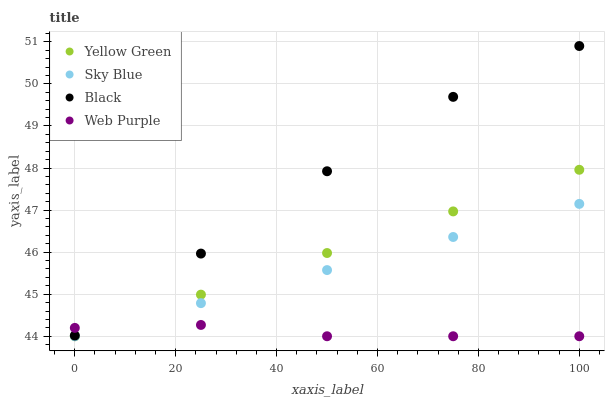Does Web Purple have the minimum area under the curve?
Answer yes or no. Yes. Does Black have the maximum area under the curve?
Answer yes or no. Yes. Does Black have the minimum area under the curve?
Answer yes or no. No. Does Web Purple have the maximum area under the curve?
Answer yes or no. No. Is Yellow Green the smoothest?
Answer yes or no. Yes. Is Black the roughest?
Answer yes or no. Yes. Is Web Purple the smoothest?
Answer yes or no. No. Is Web Purple the roughest?
Answer yes or no. No. Does Sky Blue have the lowest value?
Answer yes or no. Yes. Does Black have the lowest value?
Answer yes or no. No. Does Black have the highest value?
Answer yes or no. Yes. Does Web Purple have the highest value?
Answer yes or no. No. Is Yellow Green less than Black?
Answer yes or no. Yes. Is Black greater than Yellow Green?
Answer yes or no. Yes. Does Web Purple intersect Sky Blue?
Answer yes or no. Yes. Is Web Purple less than Sky Blue?
Answer yes or no. No. Is Web Purple greater than Sky Blue?
Answer yes or no. No. Does Yellow Green intersect Black?
Answer yes or no. No. 